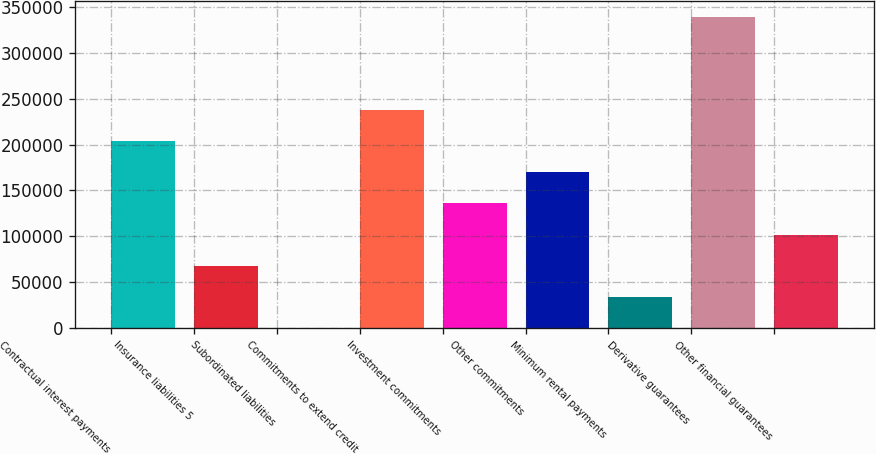<chart> <loc_0><loc_0><loc_500><loc_500><bar_chart><fcel>Contractual interest payments<fcel>Insurance liabilities 5<fcel>Subordinated liabilities<fcel>Commitments to extend credit<fcel>Investment commitments<fcel>Other commitments<fcel>Minimum rental payments<fcel>Derivative guarantees<fcel>Other financial guarantees<nl><fcel>203700<fcel>67939.2<fcel>59<fcel>237640<fcel>135819<fcel>169760<fcel>33999.1<fcel>339460<fcel>101879<nl></chart> 